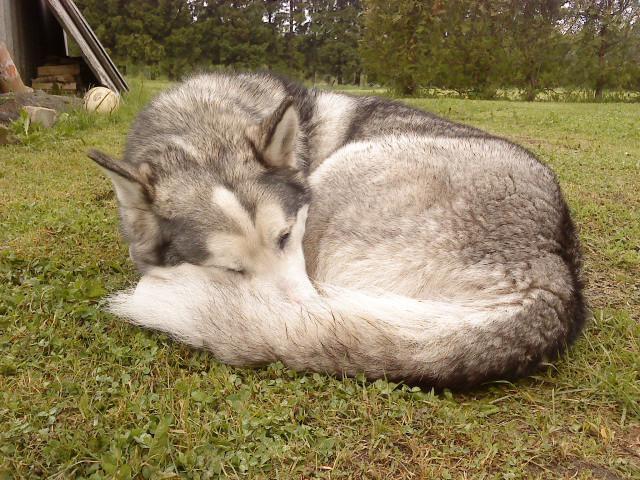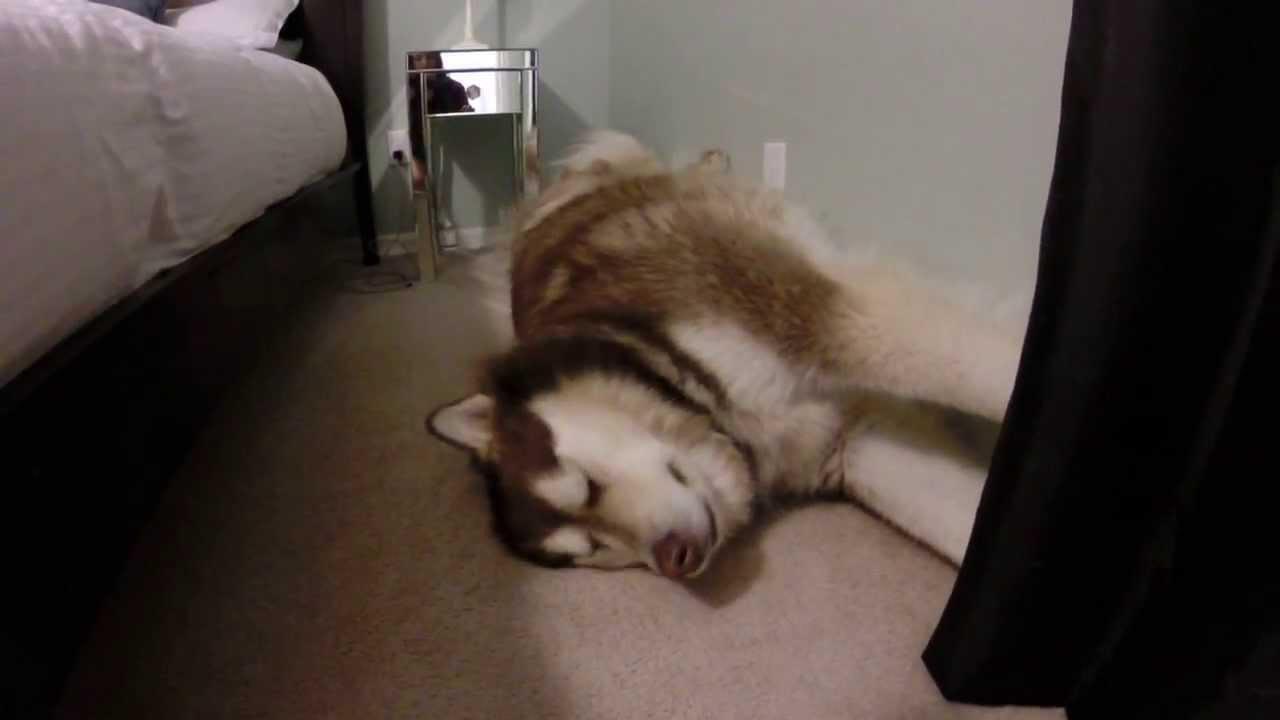The first image is the image on the left, the second image is the image on the right. For the images shown, is this caption "There is exactly one dog that is sleeping in each image." true? Answer yes or no. Yes. The first image is the image on the left, the second image is the image on the right. For the images shown, is this caption "The left image shows one husky dog reclining with its nose pointed leftward, and the right image shows some type of animal with its head on top of a reclining husky." true? Answer yes or no. No. 